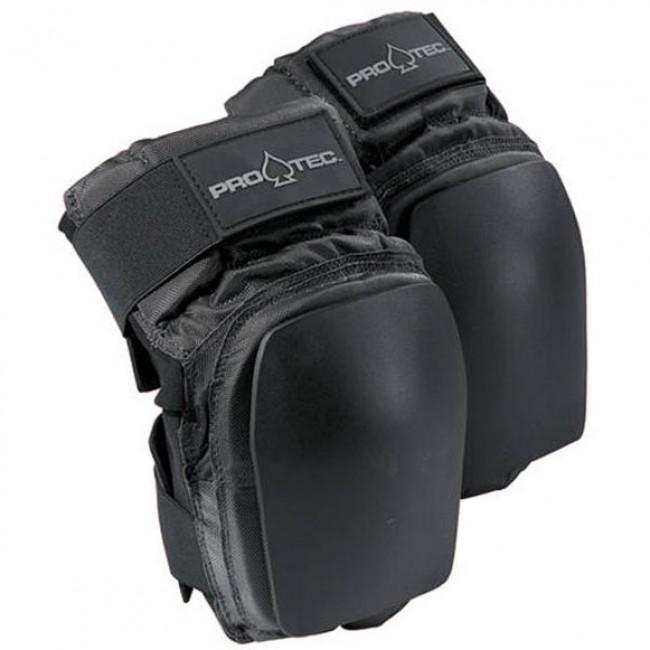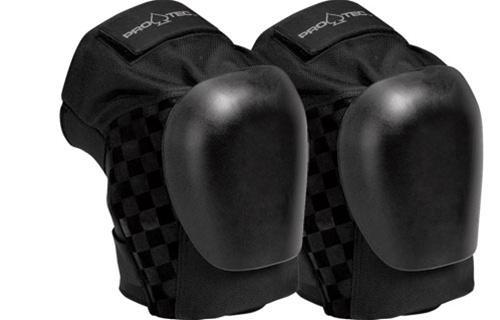The first image is the image on the left, the second image is the image on the right. Evaluate the accuracy of this statement regarding the images: "Both images contain a pair of all black knee pads". Is it true? Answer yes or no. Yes. The first image is the image on the left, the second image is the image on the right. Examine the images to the left and right. Is the description "Both knee pads are facing to the right" accurate? Answer yes or no. Yes. 